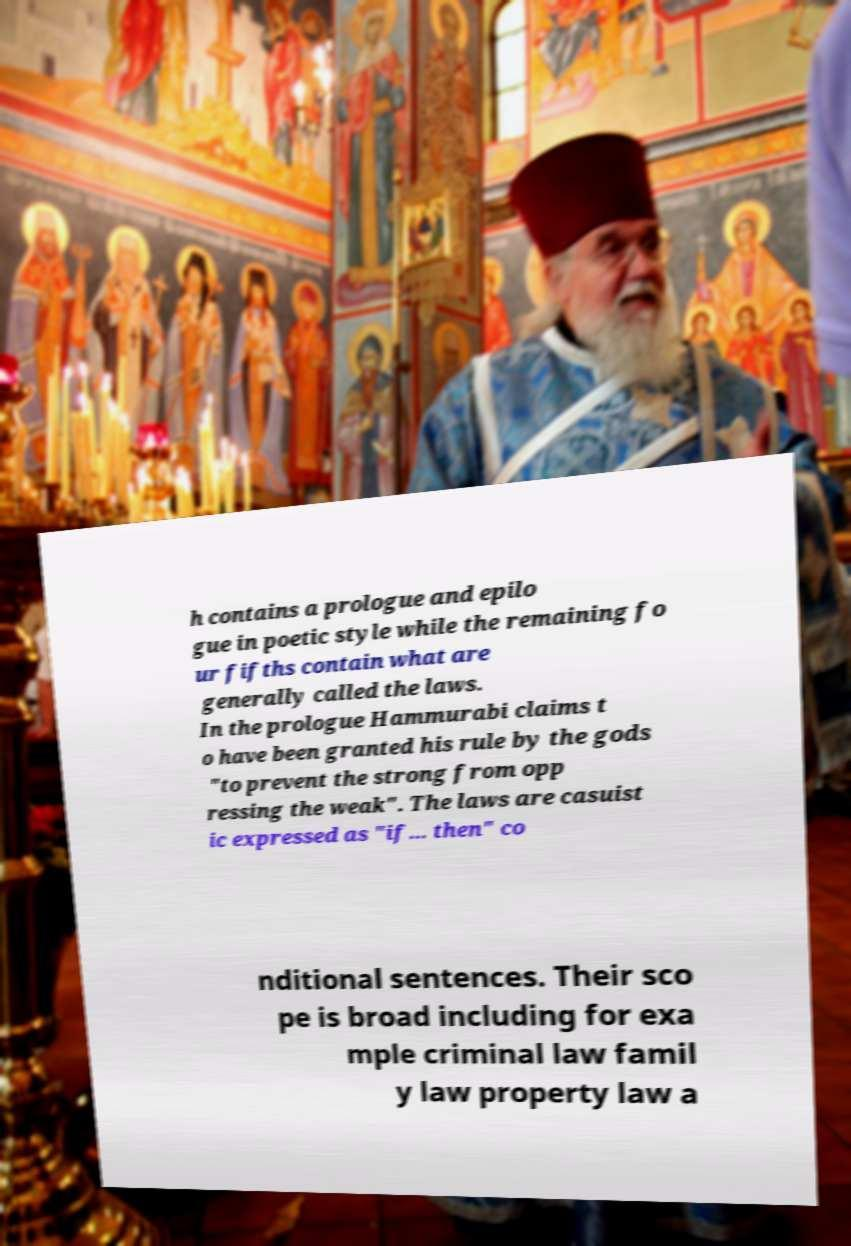Can you read and provide the text displayed in the image?This photo seems to have some interesting text. Can you extract and type it out for me? h contains a prologue and epilo gue in poetic style while the remaining fo ur fifths contain what are generally called the laws. In the prologue Hammurabi claims t o have been granted his rule by the gods "to prevent the strong from opp ressing the weak". The laws are casuist ic expressed as "if... then" co nditional sentences. Their sco pe is broad including for exa mple criminal law famil y law property law a 